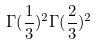<formula> <loc_0><loc_0><loc_500><loc_500>\Gamma ( \frac { 1 } { 3 } ) ^ { 2 } \Gamma ( \frac { 2 } { 3 } ) ^ { 2 }</formula> 